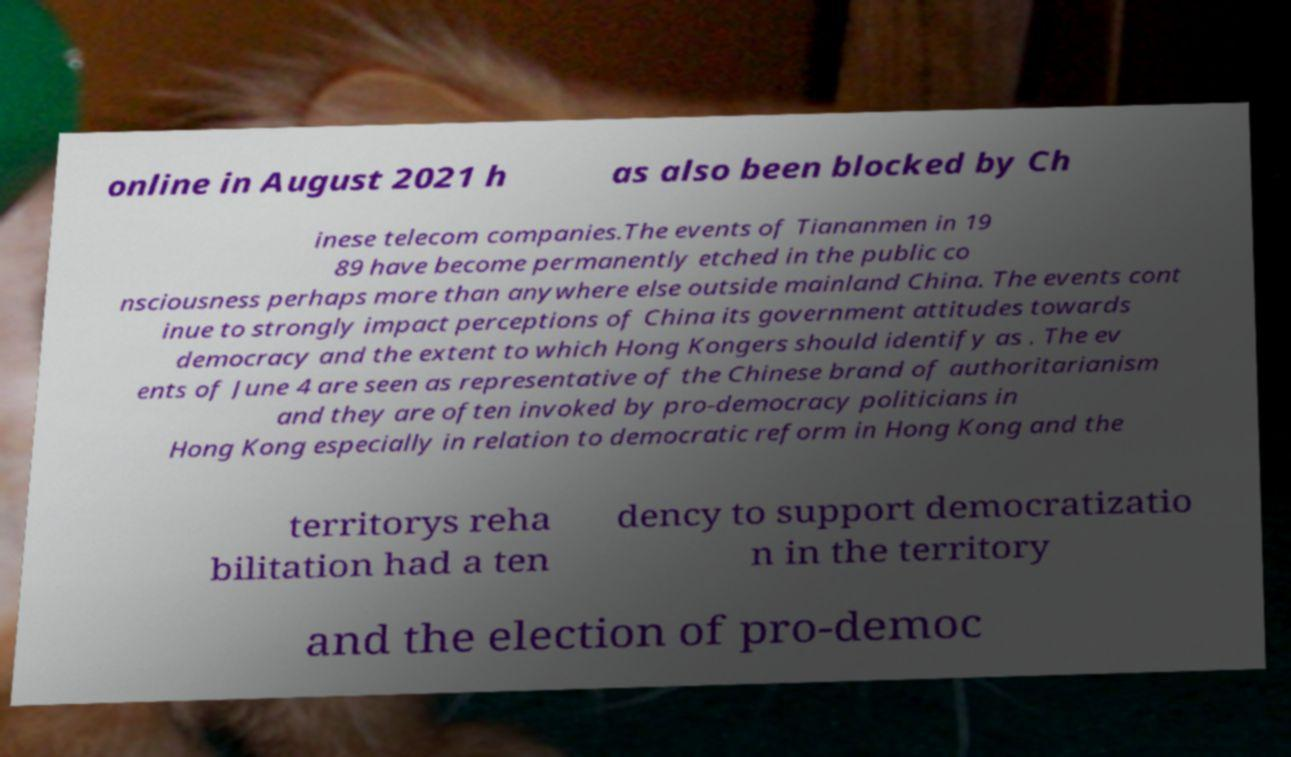Please identify and transcribe the text found in this image. online in August 2021 h as also been blocked by Ch inese telecom companies.The events of Tiananmen in 19 89 have become permanently etched in the public co nsciousness perhaps more than anywhere else outside mainland China. The events cont inue to strongly impact perceptions of China its government attitudes towards democracy and the extent to which Hong Kongers should identify as . The ev ents of June 4 are seen as representative of the Chinese brand of authoritarianism and they are often invoked by pro-democracy politicians in Hong Kong especially in relation to democratic reform in Hong Kong and the territorys reha bilitation had a ten dency to support democratizatio n in the territory and the election of pro-democ 